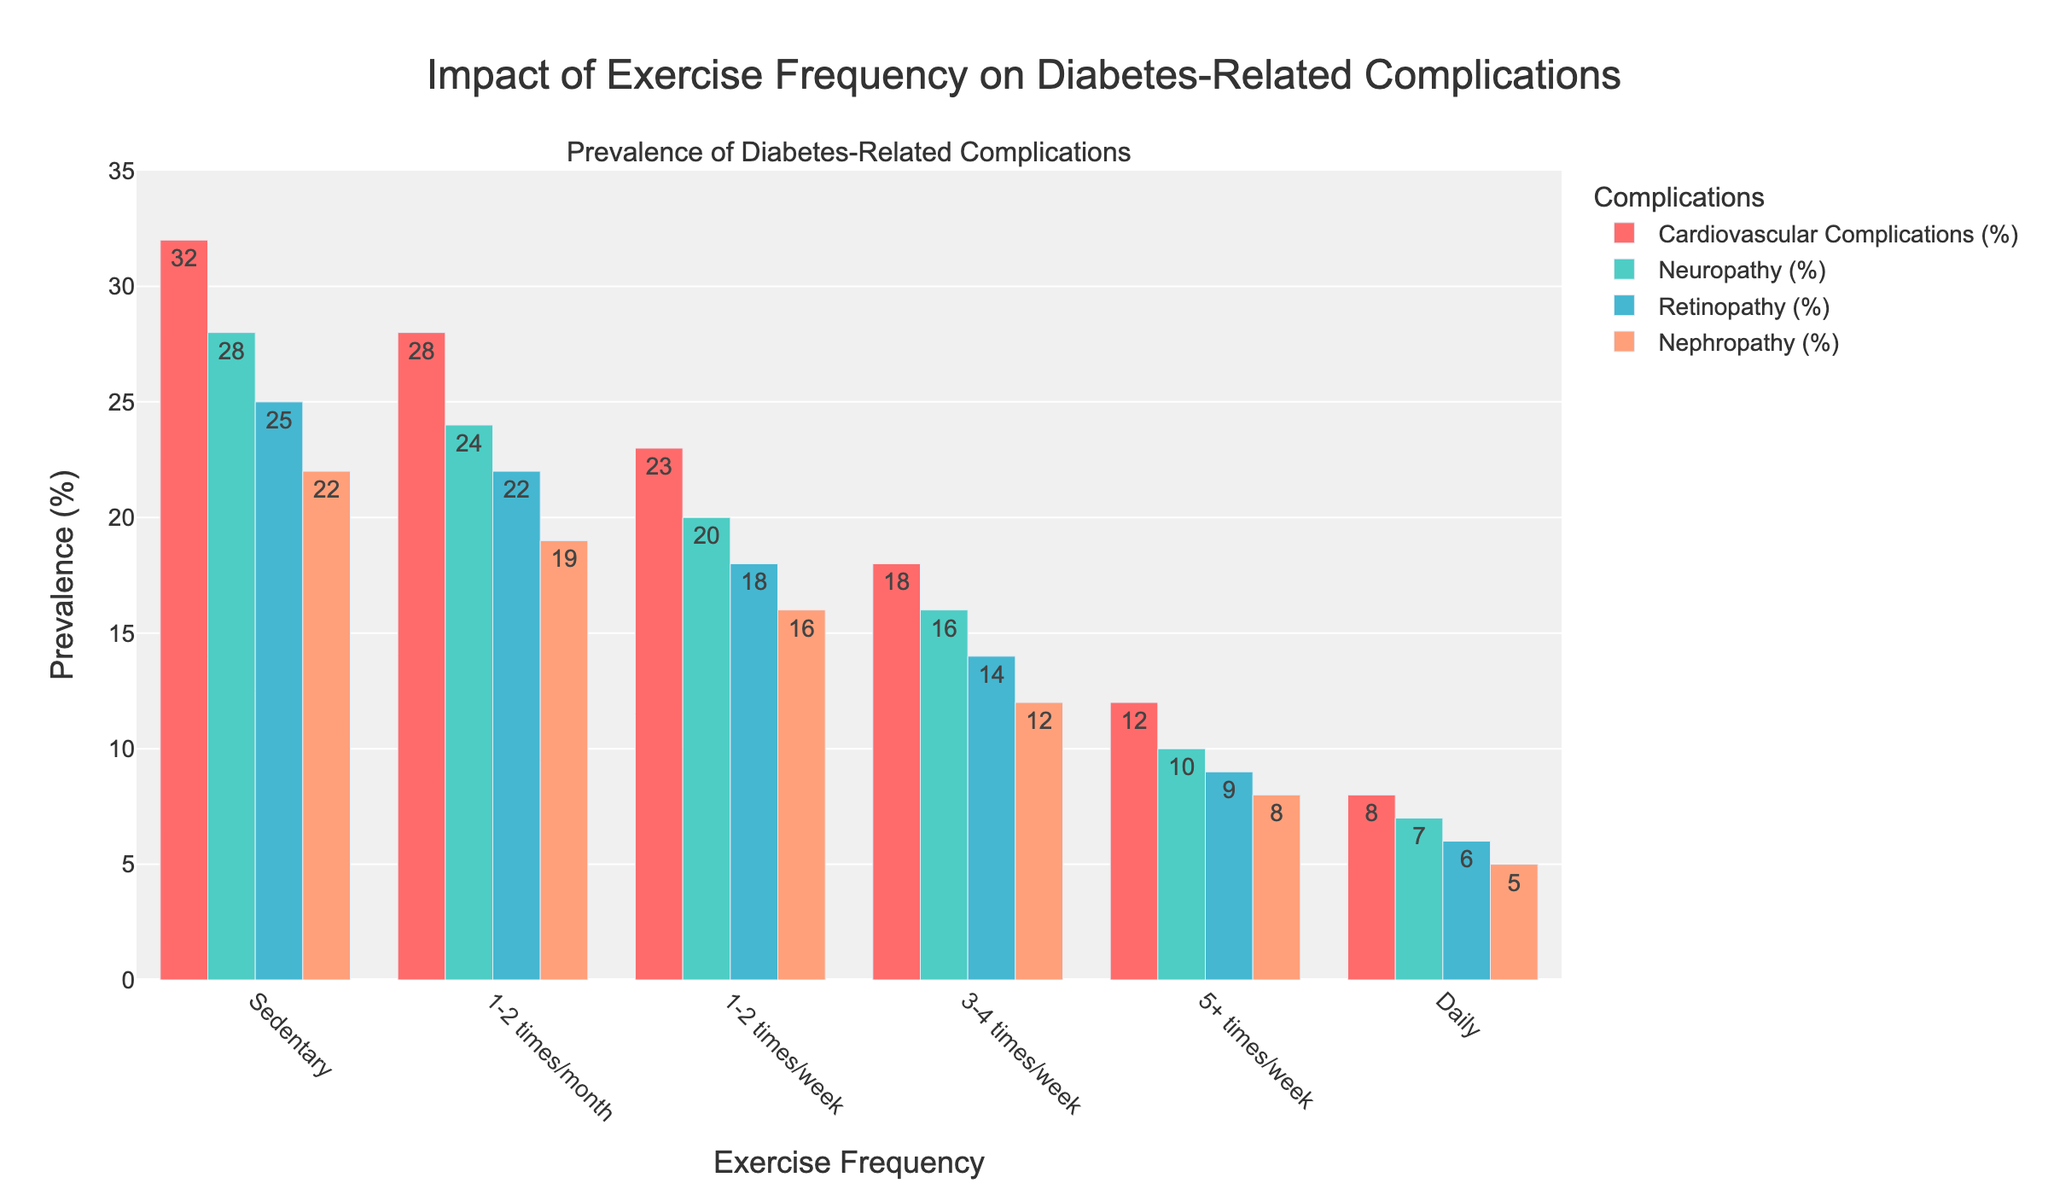Which exercise frequency corresponds to 25% prevalence of Retinopathy? According to the plot, a 25% prevalence of Retinopathy is observed among patients who are Sedentary.
Answer: Sedentary Which complication shows the greatest reduction in prevalence when comparing 'Sedentary' to 'Daily' exercise? The difference in prevalence is calculated for each complication. Cardiovascular Complications: 32% - 8% = 24%, Neuropathy: 28% - 7% = 21%, Retinopathy: 25% - 6% = 19%, Nephropathy: 22% - 5% = 17%. The greatest reduction is observed in Cardiovascular Complications.
Answer: Cardiovascular Complications What is the average prevalence of all complications for patients exercising 5+ times/week? Add the prevalence percentages of all four complications for '5+ times/week' and divide by 4: (12 + 10 + 9 + 8) / 4 = 9.75%.
Answer: 9.75% Which exercise frequency has the lowest prevalence of Nephropathy? The lowest prevalence of Nephropathy, as seen from the bars, is at the 'Daily' exercise frequency, with 5%.
Answer: Daily Compare the prevalence of Cardiovascular Complications between '1-2 times/month' and '3-4 times/week'. Which one is higher, and by how much? Cardiovascular Complications for '1-2 times/month' is 28%, and for '3-4 times/week' is 18%. The difference is 28% - 18% = 10%. The prevalence is higher in the '1-2 times/month' group by 10%.
Answer: '1-2 times/month' is higher by 10% How does the prevalence of Neuropathy change from 'Sedentary' to 'Daily'? The prevalence of Neuropathy decreases from 28% in 'Sedentary' to 7% in 'Daily'. The difference is 28% - 7% = 21%.
Answer: Decreases by 21% What is the total prevalence of all complications for the 'Sedentary' group? Sum the prevalence of all complications for the 'Sedentary' group: 32 + 28 + 25 + 22 = 107%.
Answer: 107% Between which exercise frequencies is the decrease in Neuropathy prevalence the smallest? Assess the decrease between consecutive frequencies: 'Sedentary' to '1-2 times/month' (28% - 24% = 4%), '1-2 times/month' to '1-2 times/week' (24% - 20% = 4%), '1-2 times/week' to '3-4 times/week' (20% - 16% = 4%), '3-4 times/week' to '5+ times/week' (16% - 10% = 6%), '5+ times/week' to 'Daily' (10% - 7% = 3%). The smallest decrease is between 'Sedentary' and '1-2 times/month', '1-2 times/month' and '1-2 times/week', '1-2 times/week' and '3-4 times/week', all by 4%.
Answer: 'Sedentary' to '1-2 times/month', '1-2 times/month' to '1-2 times/week', '1-2 times/week' to '3-4 times/week' (all by 4%) Which exercise frequency shows a 10% prevalence of Neuropathy? According to the plot, a 10% prevalence of Neuropathy is observed among patients who exercise '5+ times/week'.
Answer: 5+ times/week 